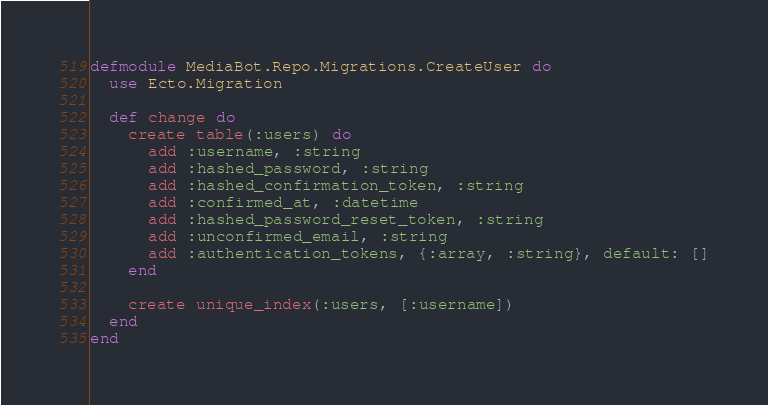Convert code to text. <code><loc_0><loc_0><loc_500><loc_500><_Elixir_>defmodule MediaBot.Repo.Migrations.CreateUser do
  use Ecto.Migration

  def change do
    create table(:users) do
      add :username, :string
      add :hashed_password, :string
      add :hashed_confirmation_token, :string
      add :confirmed_at, :datetime
      add :hashed_password_reset_token, :string
      add :unconfirmed_email, :string
      add :authentication_tokens, {:array, :string}, default: []
    end

    create unique_index(:users, [:username])
  end
end
</code> 